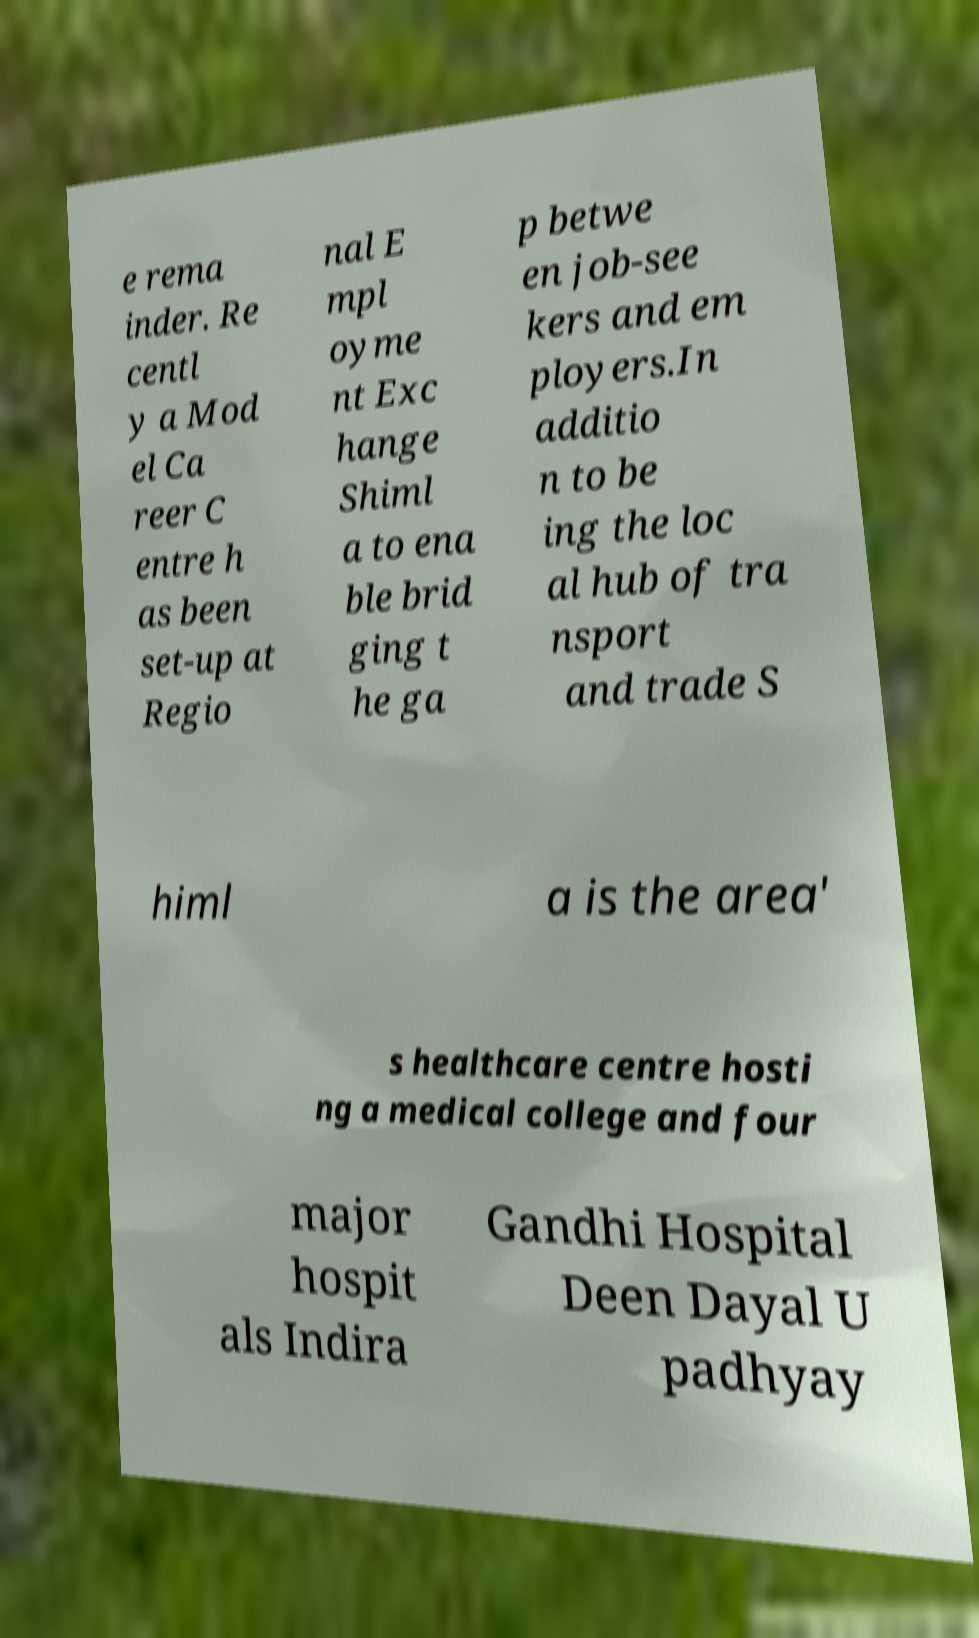What messages or text are displayed in this image? I need them in a readable, typed format. e rema inder. Re centl y a Mod el Ca reer C entre h as been set-up at Regio nal E mpl oyme nt Exc hange Shiml a to ena ble brid ging t he ga p betwe en job-see kers and em ployers.In additio n to be ing the loc al hub of tra nsport and trade S himl a is the area' s healthcare centre hosti ng a medical college and four major hospit als Indira Gandhi Hospital Deen Dayal U padhyay 